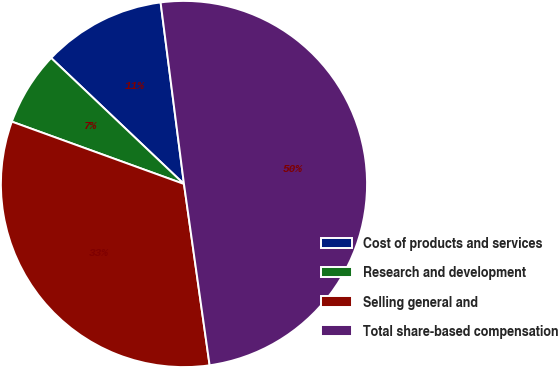Convert chart to OTSL. <chart><loc_0><loc_0><loc_500><loc_500><pie_chart><fcel>Cost of products and services<fcel>Research and development<fcel>Selling general and<fcel>Total share-based compensation<nl><fcel>10.88%<fcel>6.55%<fcel>32.77%<fcel>49.8%<nl></chart> 